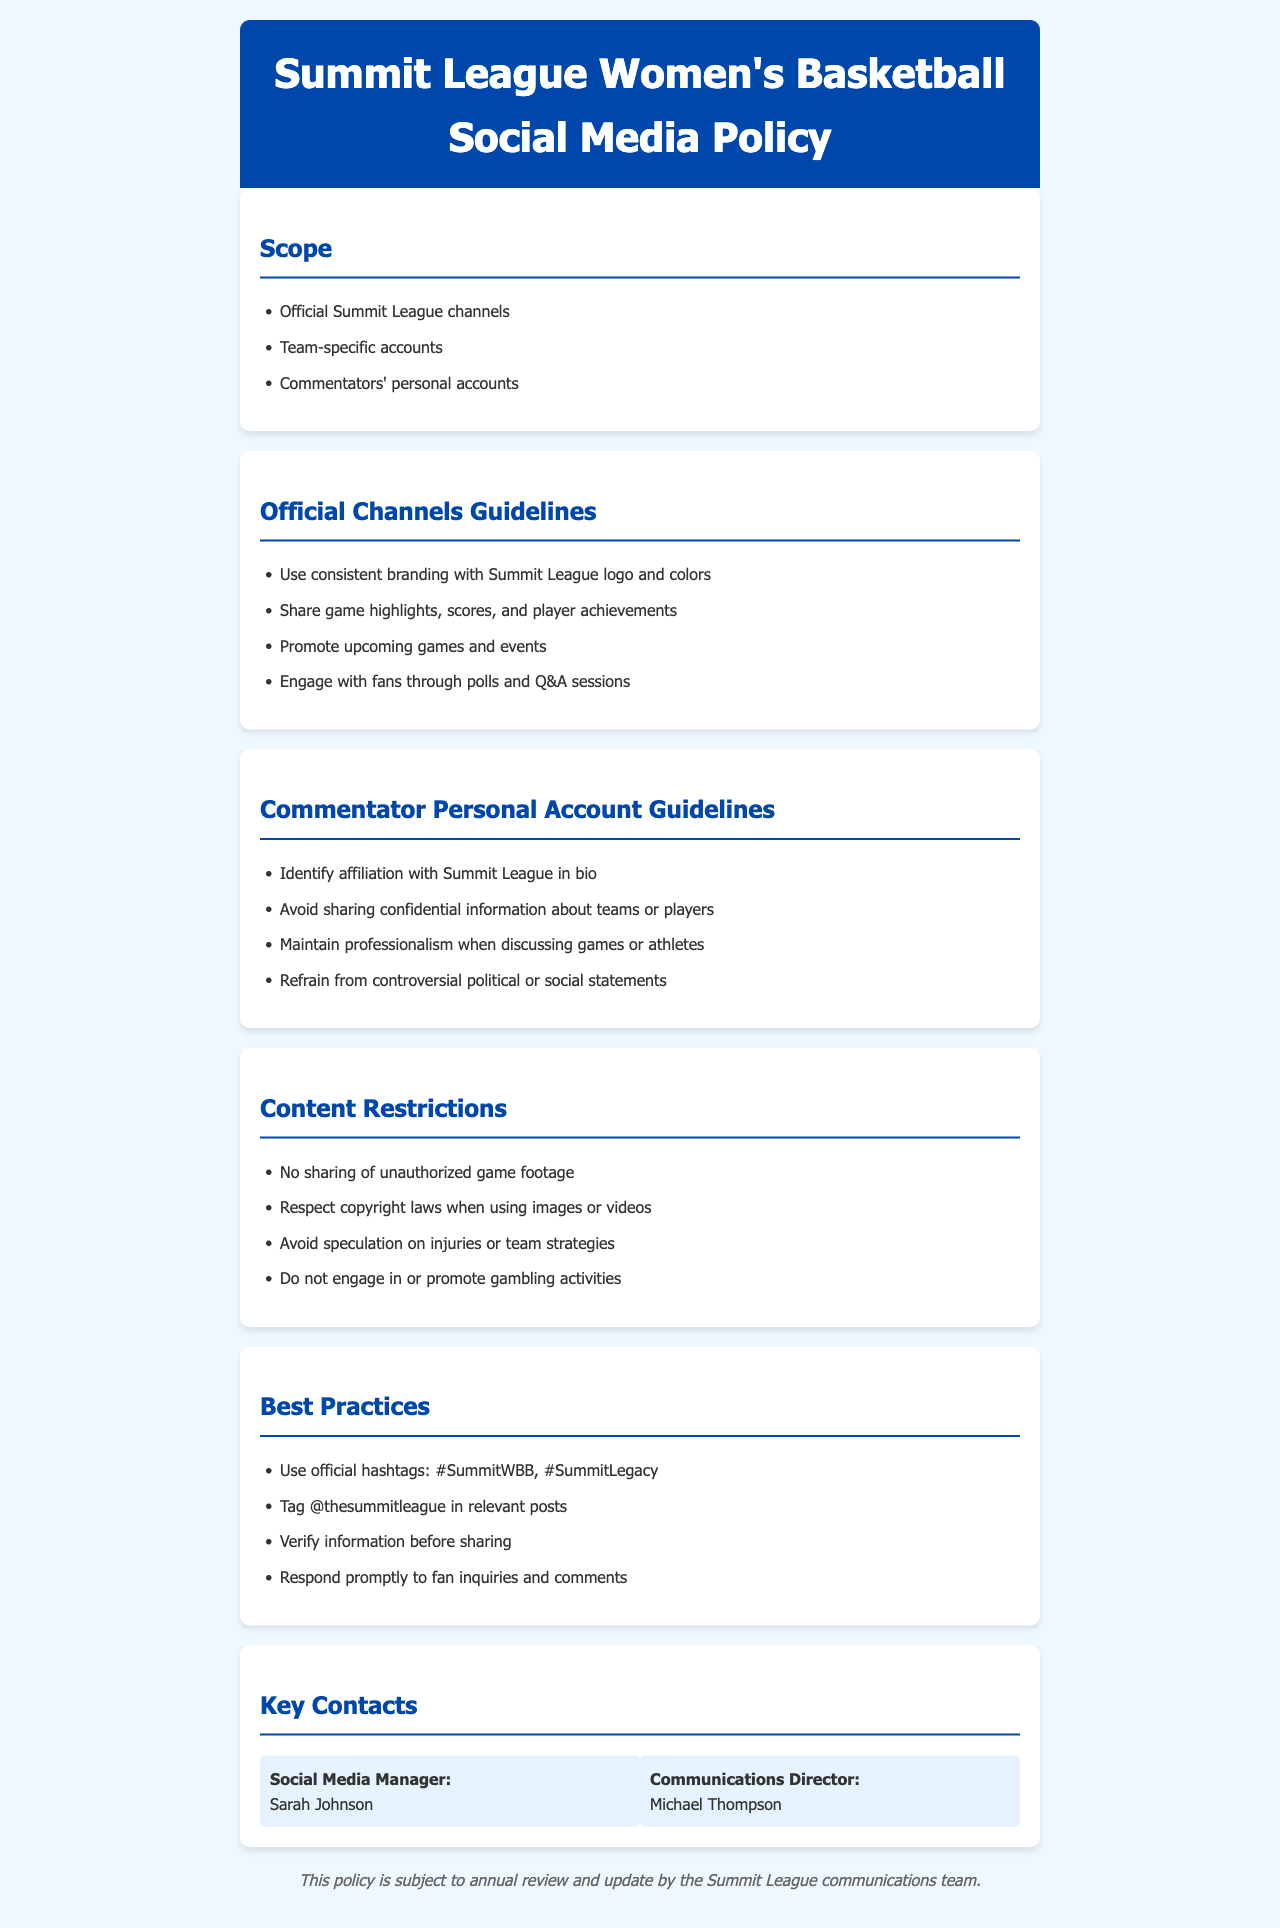What are the official channels covered by the policy? The document lists "Official Summit League channels," "Team-specific accounts," and "Commentators' personal accounts" as the scope of the policy.
Answer: Official Summit League channels, Team-specific accounts, Commentators' personal accounts What should commentators avoid sharing on their personal accounts? The policy states that commentators should "Avoid sharing confidential information about teams or players."
Answer: Confidential information What is a requirement for commentators when using their personal accounts? The document specifies that commentators must "Identify affiliation with Summit League in bio."
Answer: Identify affiliation What is one of the content restrictions mentioned in the policy? The document lists "No sharing of unauthorized game footage" as a restriction.
Answer: No sharing of unauthorized game footage Which two hashtags should commentators use? The best practices section recommends using "#SummitWBB" and "#SummitLegacy."
Answer: #SummitWBB, #SummitLegacy Who is listed as the Social Media Manager? The document specifies "Sarah Johnson" as the Social Media Manager in the key contacts section.
Answer: Sarah Johnson What should commentators do before sharing information? The best practices state that commentators should "Verify information before sharing."
Answer: Verify information Why should commentators refrain from controversial statements? The policy guides commentators to "Maintain professionalism when discussing games or athletes" and to "Refrain from controversial political or social statements."
Answer: Professionalism 